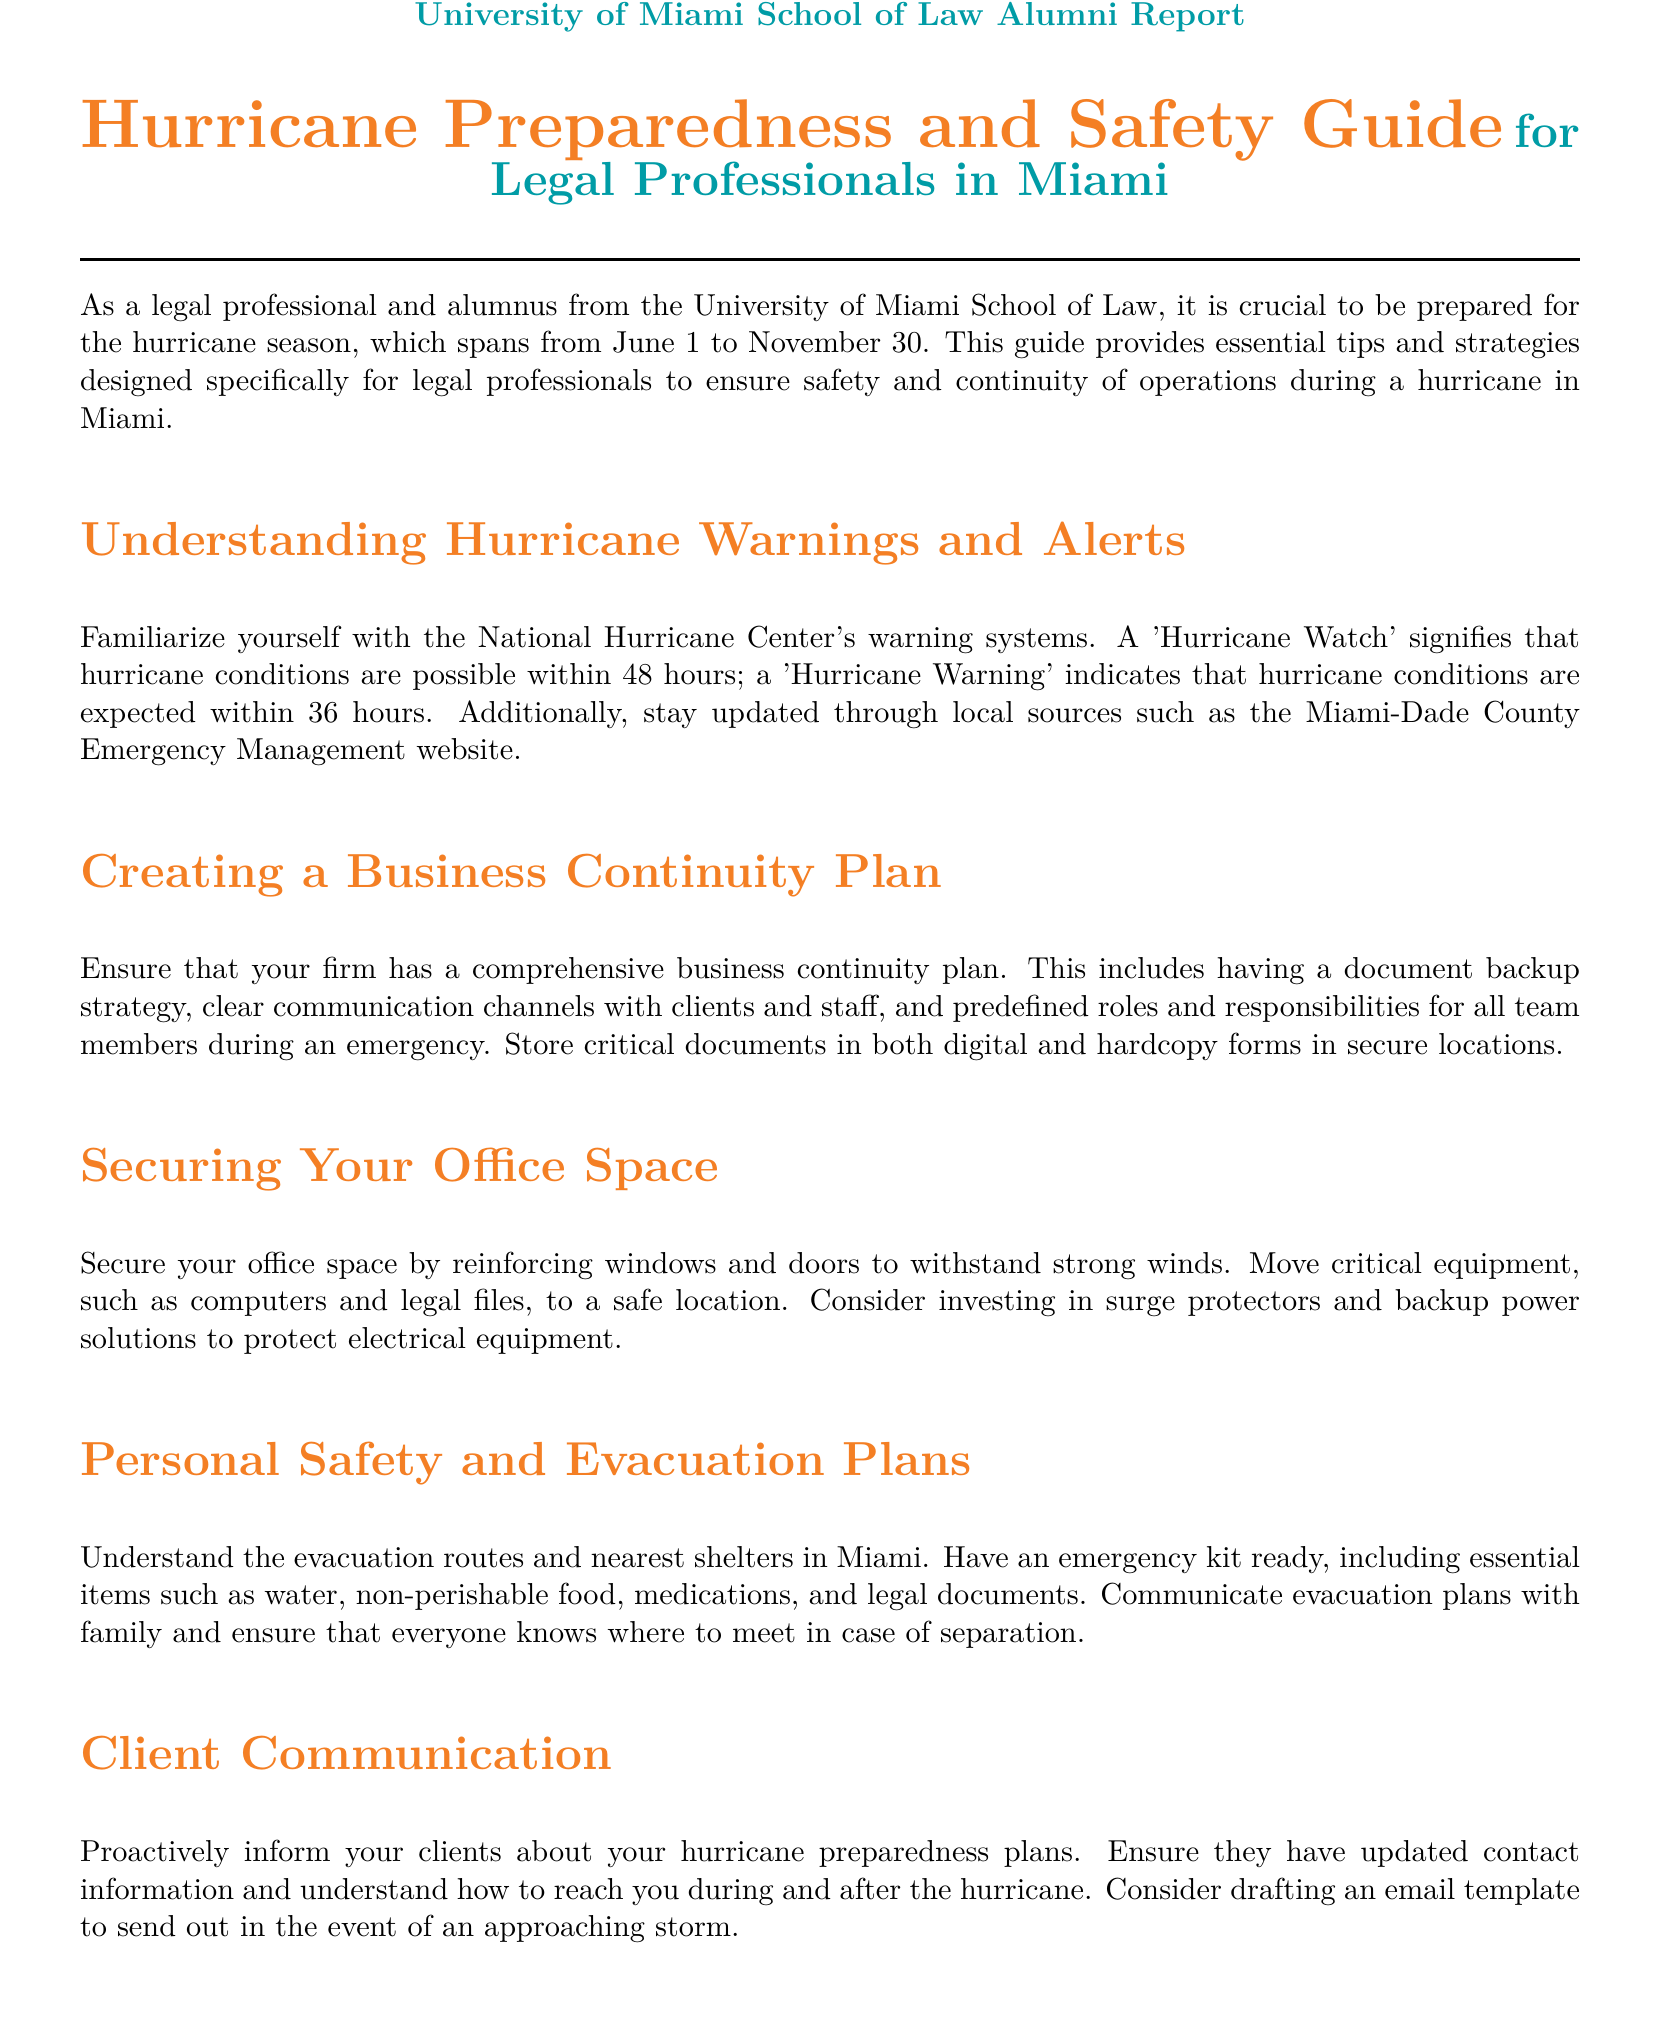What are the dates for hurricane season? The document states that hurricane season spans from June 1 to November 30.
Answer: June 1 to November 30 What should be included in an emergency kit? The document lists essential items for an emergency kit, including water, non-perishable food, medications, and legal documents.
Answer: Water, non-perishable food, medications, legal documents What does a 'Hurricane Watch' indicate? The document explains that a 'Hurricane Watch' signifies that hurricane conditions are possible within 48 hours.
Answer: Possible within 48 hours What is the purpose of a business continuity plan? The document mentions that a business continuity plan helps ensure clear communication, document backups, and defined roles during an emergency.
Answer: Clear communication, document backups, defined roles What should legal professionals do to secure their office space? The guide suggests reinforcing windows and doors, moving critical equipment to a safe location, and investing in surge protectors.
Answer: Reinforcing windows and doors How can legal professionals communicate with clients during a hurricane? The document advises proactively informing clients about hurricane preparedness plans and providing updated contact information.
Answer: Proactively inform clients What action should be taken post-hurricane regarding office damage? The document mentions assessing any damage to office and legal records after the hurricane has passed.
Answer: Assess damage What platforms can be leveraged for remote work during recovery? The document refers to legal technology platforms that can be used for remote work after a hurricane.
Answer: Legal technology platforms What color is used for section titles in the document? The document utilizes the color miamiorange for section titles.
Answer: miamiorange 